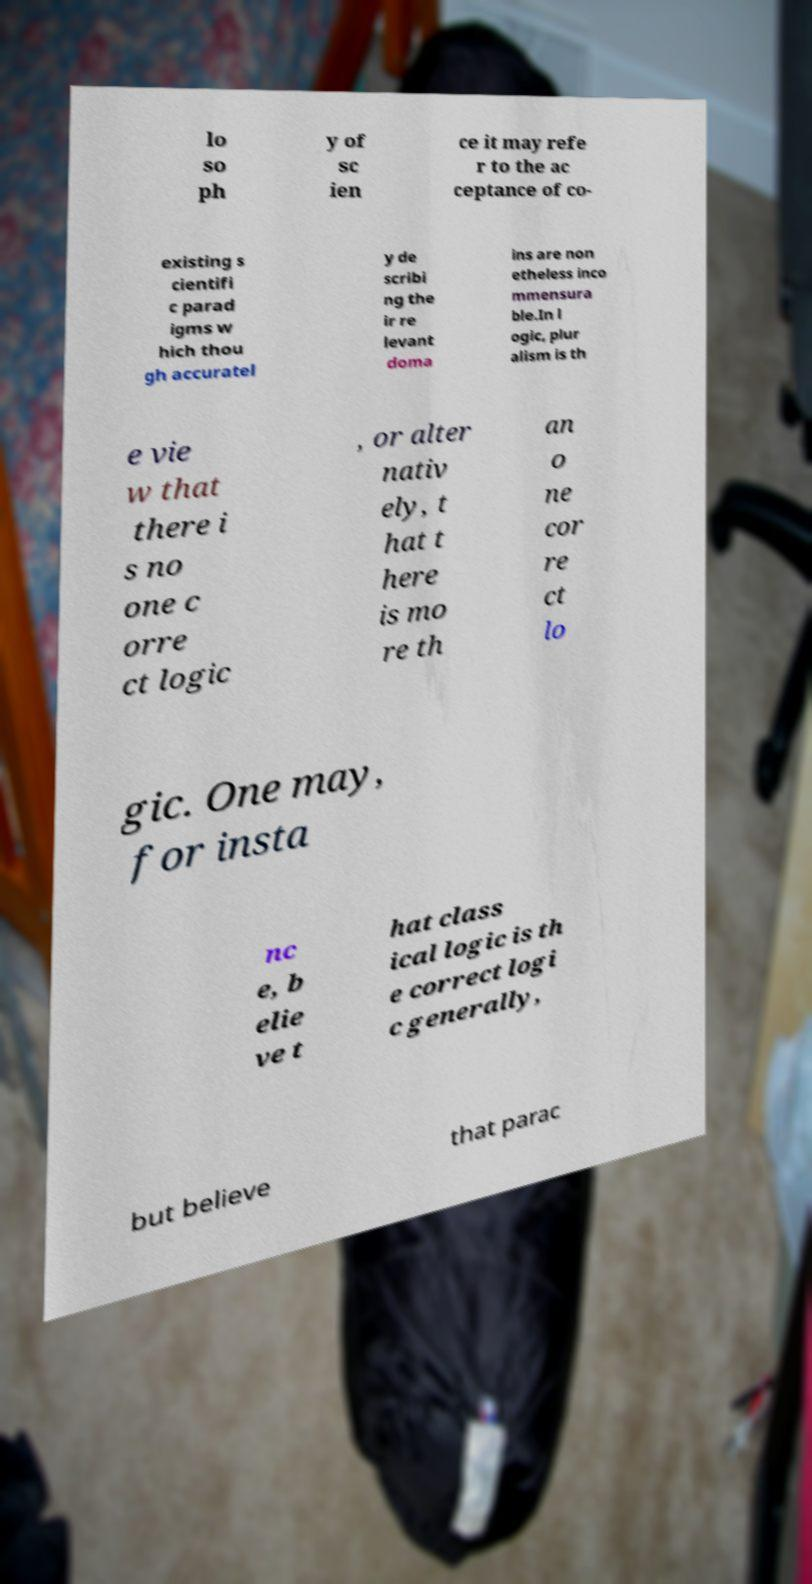There's text embedded in this image that I need extracted. Can you transcribe it verbatim? lo so ph y of sc ien ce it may refe r to the ac ceptance of co- existing s cientifi c parad igms w hich thou gh accuratel y de scribi ng the ir re levant doma ins are non etheless inco mmensura ble.In l ogic, plur alism is th e vie w that there i s no one c orre ct logic , or alter nativ ely, t hat t here is mo re th an o ne cor re ct lo gic. One may, for insta nc e, b elie ve t hat class ical logic is th e correct logi c generally, but believe that parac 